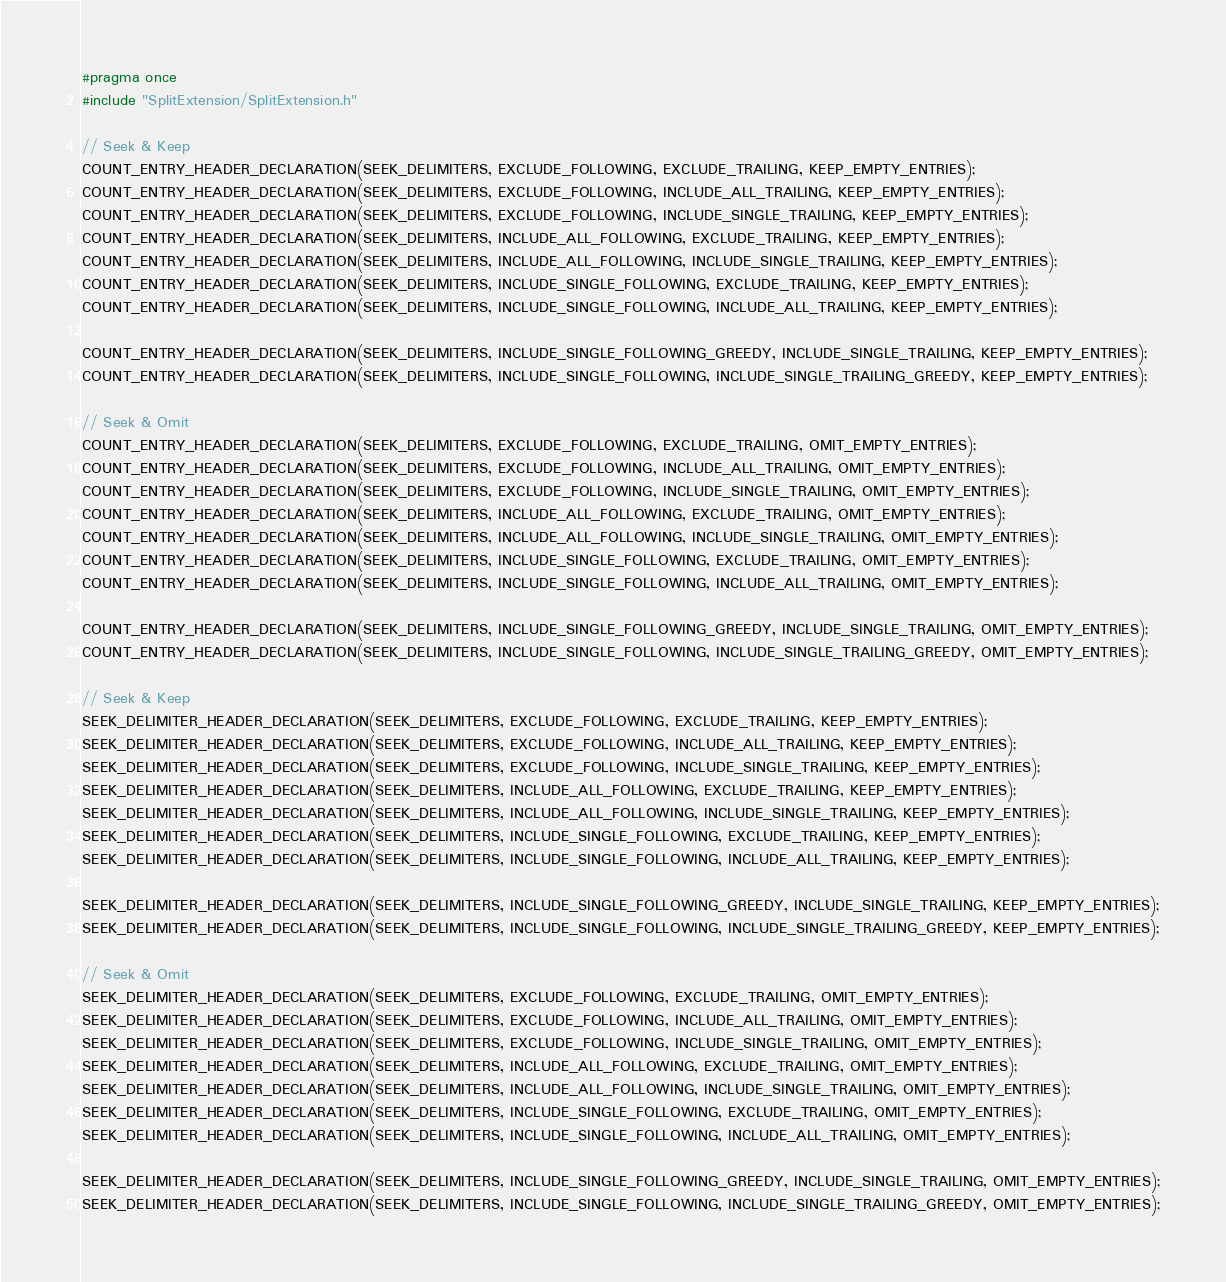Convert code to text. <code><loc_0><loc_0><loc_500><loc_500><_C_>#pragma once
#include "SplitExtension/SplitExtension.h"

// Seek & Keep
COUNT_ENTRY_HEADER_DECLARATION(SEEK_DELIMITERS, EXCLUDE_FOLLOWING, EXCLUDE_TRAILING, KEEP_EMPTY_ENTRIES);
COUNT_ENTRY_HEADER_DECLARATION(SEEK_DELIMITERS, EXCLUDE_FOLLOWING, INCLUDE_ALL_TRAILING, KEEP_EMPTY_ENTRIES);
COUNT_ENTRY_HEADER_DECLARATION(SEEK_DELIMITERS, EXCLUDE_FOLLOWING, INCLUDE_SINGLE_TRAILING, KEEP_EMPTY_ENTRIES);
COUNT_ENTRY_HEADER_DECLARATION(SEEK_DELIMITERS, INCLUDE_ALL_FOLLOWING, EXCLUDE_TRAILING, KEEP_EMPTY_ENTRIES);
COUNT_ENTRY_HEADER_DECLARATION(SEEK_DELIMITERS, INCLUDE_ALL_FOLLOWING, INCLUDE_SINGLE_TRAILING, KEEP_EMPTY_ENTRIES);
COUNT_ENTRY_HEADER_DECLARATION(SEEK_DELIMITERS, INCLUDE_SINGLE_FOLLOWING, EXCLUDE_TRAILING, KEEP_EMPTY_ENTRIES);
COUNT_ENTRY_HEADER_DECLARATION(SEEK_DELIMITERS, INCLUDE_SINGLE_FOLLOWING, INCLUDE_ALL_TRAILING, KEEP_EMPTY_ENTRIES);

COUNT_ENTRY_HEADER_DECLARATION(SEEK_DELIMITERS, INCLUDE_SINGLE_FOLLOWING_GREEDY, INCLUDE_SINGLE_TRAILING, KEEP_EMPTY_ENTRIES);
COUNT_ENTRY_HEADER_DECLARATION(SEEK_DELIMITERS, INCLUDE_SINGLE_FOLLOWING, INCLUDE_SINGLE_TRAILING_GREEDY, KEEP_EMPTY_ENTRIES);

// Seek & Omit
COUNT_ENTRY_HEADER_DECLARATION(SEEK_DELIMITERS, EXCLUDE_FOLLOWING, EXCLUDE_TRAILING, OMIT_EMPTY_ENTRIES);
COUNT_ENTRY_HEADER_DECLARATION(SEEK_DELIMITERS, EXCLUDE_FOLLOWING, INCLUDE_ALL_TRAILING, OMIT_EMPTY_ENTRIES);
COUNT_ENTRY_HEADER_DECLARATION(SEEK_DELIMITERS, EXCLUDE_FOLLOWING, INCLUDE_SINGLE_TRAILING, OMIT_EMPTY_ENTRIES);
COUNT_ENTRY_HEADER_DECLARATION(SEEK_DELIMITERS, INCLUDE_ALL_FOLLOWING, EXCLUDE_TRAILING, OMIT_EMPTY_ENTRIES);
COUNT_ENTRY_HEADER_DECLARATION(SEEK_DELIMITERS, INCLUDE_ALL_FOLLOWING, INCLUDE_SINGLE_TRAILING, OMIT_EMPTY_ENTRIES);
COUNT_ENTRY_HEADER_DECLARATION(SEEK_DELIMITERS, INCLUDE_SINGLE_FOLLOWING, EXCLUDE_TRAILING, OMIT_EMPTY_ENTRIES);
COUNT_ENTRY_HEADER_DECLARATION(SEEK_DELIMITERS, INCLUDE_SINGLE_FOLLOWING, INCLUDE_ALL_TRAILING, OMIT_EMPTY_ENTRIES);

COUNT_ENTRY_HEADER_DECLARATION(SEEK_DELIMITERS, INCLUDE_SINGLE_FOLLOWING_GREEDY, INCLUDE_SINGLE_TRAILING, OMIT_EMPTY_ENTRIES);
COUNT_ENTRY_HEADER_DECLARATION(SEEK_DELIMITERS, INCLUDE_SINGLE_FOLLOWING, INCLUDE_SINGLE_TRAILING_GREEDY, OMIT_EMPTY_ENTRIES);

// Seek & Keep
SEEK_DELIMITER_HEADER_DECLARATION(SEEK_DELIMITERS, EXCLUDE_FOLLOWING, EXCLUDE_TRAILING, KEEP_EMPTY_ENTRIES);
SEEK_DELIMITER_HEADER_DECLARATION(SEEK_DELIMITERS, EXCLUDE_FOLLOWING, INCLUDE_ALL_TRAILING, KEEP_EMPTY_ENTRIES);
SEEK_DELIMITER_HEADER_DECLARATION(SEEK_DELIMITERS, EXCLUDE_FOLLOWING, INCLUDE_SINGLE_TRAILING, KEEP_EMPTY_ENTRIES);
SEEK_DELIMITER_HEADER_DECLARATION(SEEK_DELIMITERS, INCLUDE_ALL_FOLLOWING, EXCLUDE_TRAILING, KEEP_EMPTY_ENTRIES);
SEEK_DELIMITER_HEADER_DECLARATION(SEEK_DELIMITERS, INCLUDE_ALL_FOLLOWING, INCLUDE_SINGLE_TRAILING, KEEP_EMPTY_ENTRIES);
SEEK_DELIMITER_HEADER_DECLARATION(SEEK_DELIMITERS, INCLUDE_SINGLE_FOLLOWING, EXCLUDE_TRAILING, KEEP_EMPTY_ENTRIES);
SEEK_DELIMITER_HEADER_DECLARATION(SEEK_DELIMITERS, INCLUDE_SINGLE_FOLLOWING, INCLUDE_ALL_TRAILING, KEEP_EMPTY_ENTRIES);

SEEK_DELIMITER_HEADER_DECLARATION(SEEK_DELIMITERS, INCLUDE_SINGLE_FOLLOWING_GREEDY, INCLUDE_SINGLE_TRAILING, KEEP_EMPTY_ENTRIES);
SEEK_DELIMITER_HEADER_DECLARATION(SEEK_DELIMITERS, INCLUDE_SINGLE_FOLLOWING, INCLUDE_SINGLE_TRAILING_GREEDY, KEEP_EMPTY_ENTRIES);

// Seek & Omit
SEEK_DELIMITER_HEADER_DECLARATION(SEEK_DELIMITERS, EXCLUDE_FOLLOWING, EXCLUDE_TRAILING, OMIT_EMPTY_ENTRIES);
SEEK_DELIMITER_HEADER_DECLARATION(SEEK_DELIMITERS, EXCLUDE_FOLLOWING, INCLUDE_ALL_TRAILING, OMIT_EMPTY_ENTRIES);
SEEK_DELIMITER_HEADER_DECLARATION(SEEK_DELIMITERS, EXCLUDE_FOLLOWING, INCLUDE_SINGLE_TRAILING, OMIT_EMPTY_ENTRIES);
SEEK_DELIMITER_HEADER_DECLARATION(SEEK_DELIMITERS, INCLUDE_ALL_FOLLOWING, EXCLUDE_TRAILING, OMIT_EMPTY_ENTRIES);
SEEK_DELIMITER_HEADER_DECLARATION(SEEK_DELIMITERS, INCLUDE_ALL_FOLLOWING, INCLUDE_SINGLE_TRAILING, OMIT_EMPTY_ENTRIES);
SEEK_DELIMITER_HEADER_DECLARATION(SEEK_DELIMITERS, INCLUDE_SINGLE_FOLLOWING, EXCLUDE_TRAILING, OMIT_EMPTY_ENTRIES);
SEEK_DELIMITER_HEADER_DECLARATION(SEEK_DELIMITERS, INCLUDE_SINGLE_FOLLOWING, INCLUDE_ALL_TRAILING, OMIT_EMPTY_ENTRIES);

SEEK_DELIMITER_HEADER_DECLARATION(SEEK_DELIMITERS, INCLUDE_SINGLE_FOLLOWING_GREEDY, INCLUDE_SINGLE_TRAILING, OMIT_EMPTY_ENTRIES);
SEEK_DELIMITER_HEADER_DECLARATION(SEEK_DELIMITERS, INCLUDE_SINGLE_FOLLOWING, INCLUDE_SINGLE_TRAILING_GREEDY, OMIT_EMPTY_ENTRIES);





</code> 